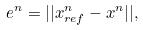<formula> <loc_0><loc_0><loc_500><loc_500>e ^ { n } = | | x ^ { n } _ { r e f } - x ^ { n } | | ,</formula> 